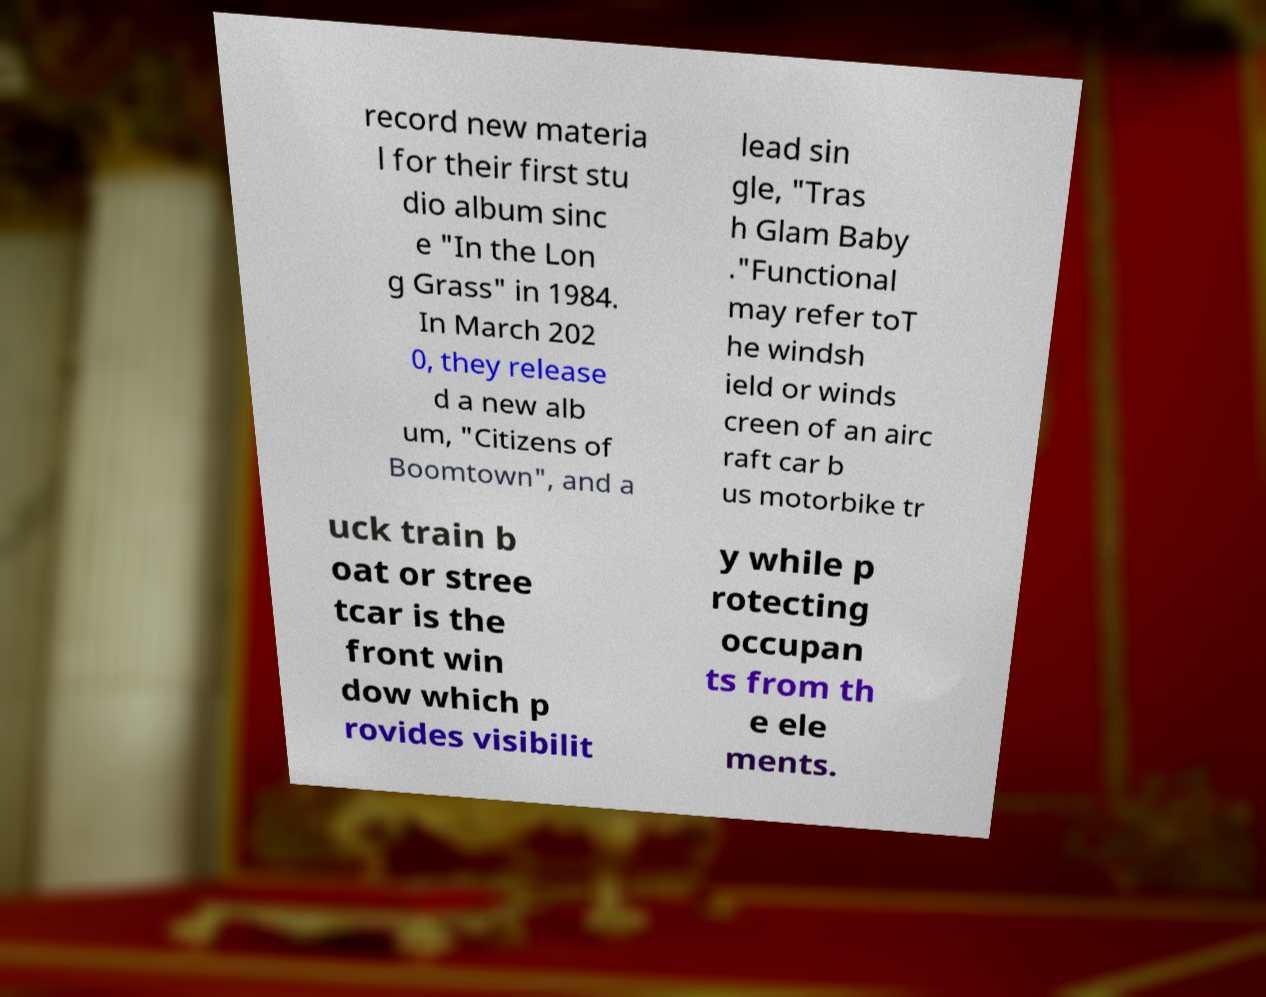Can you accurately transcribe the text from the provided image for me? record new materia l for their first stu dio album sinc e "In the Lon g Grass" in 1984. In March 202 0, they release d a new alb um, "Citizens of Boomtown", and a lead sin gle, "Tras h Glam Baby ."Functional may refer toT he windsh ield or winds creen of an airc raft car b us motorbike tr uck train b oat or stree tcar is the front win dow which p rovides visibilit y while p rotecting occupan ts from th e ele ments. 